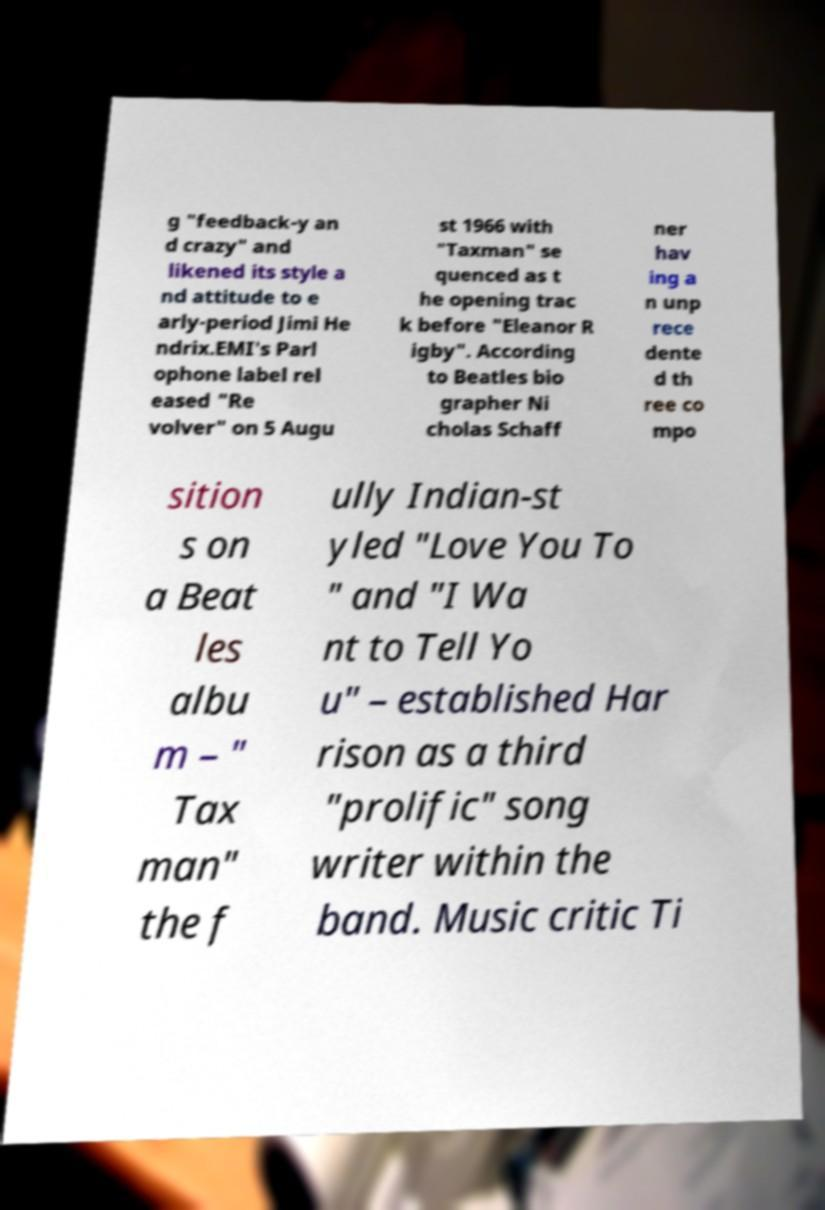Can you read and provide the text displayed in the image?This photo seems to have some interesting text. Can you extract and type it out for me? g "feedback-y an d crazy" and likened its style a nd attitude to e arly-period Jimi He ndrix.EMI's Parl ophone label rel eased "Re volver" on 5 Augu st 1966 with "Taxman" se quenced as t he opening trac k before "Eleanor R igby". According to Beatles bio grapher Ni cholas Schaff ner hav ing a n unp rece dente d th ree co mpo sition s on a Beat les albu m – " Tax man" the f ully Indian-st yled "Love You To " and "I Wa nt to Tell Yo u" – established Har rison as a third "prolific" song writer within the band. Music critic Ti 